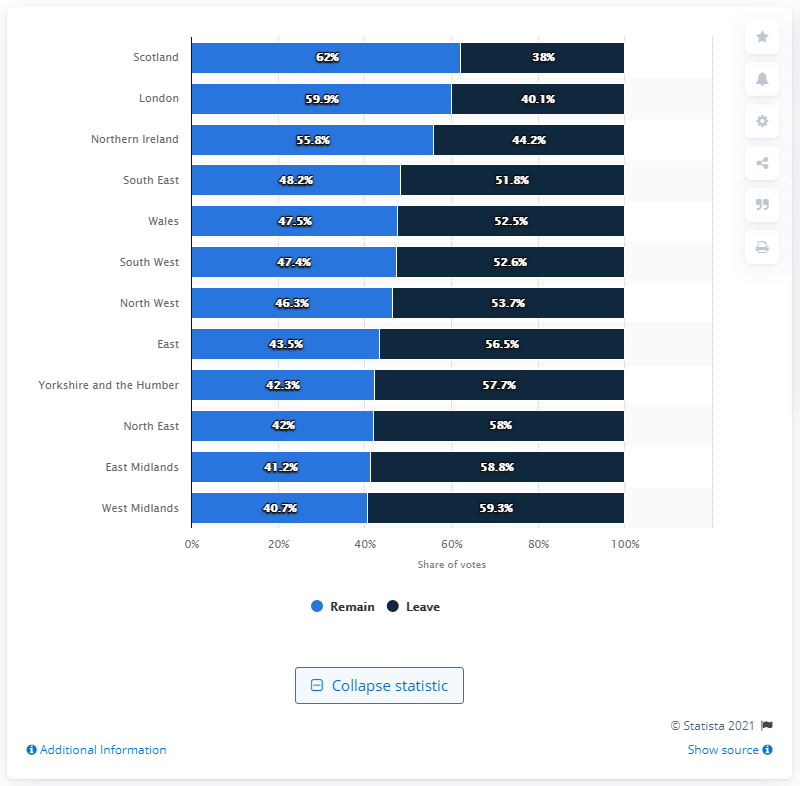Indicate a few pertinent items in this graphic. The West Midlands has the least share of remain of all regions in the United Kingdom. In Scotland, the remain vote share was 62%. 